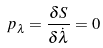<formula> <loc_0><loc_0><loc_500><loc_500>p _ { \lambda } = \frac { \delta S } { \delta \dot { \lambda } } = 0</formula> 